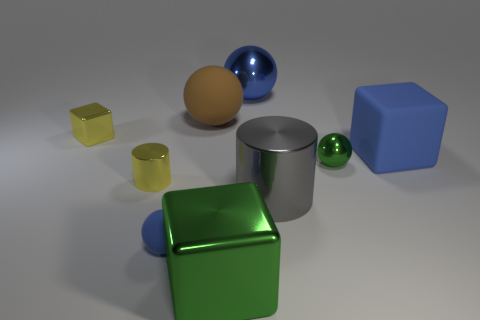Subtract all blocks. How many objects are left? 6 Add 7 matte spheres. How many matte spheres are left? 9 Add 3 large gray objects. How many large gray objects exist? 4 Subtract 1 blue cubes. How many objects are left? 8 Subtract all metal cylinders. Subtract all large blue things. How many objects are left? 5 